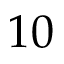<formula> <loc_0><loc_0><loc_500><loc_500>1 0</formula> 